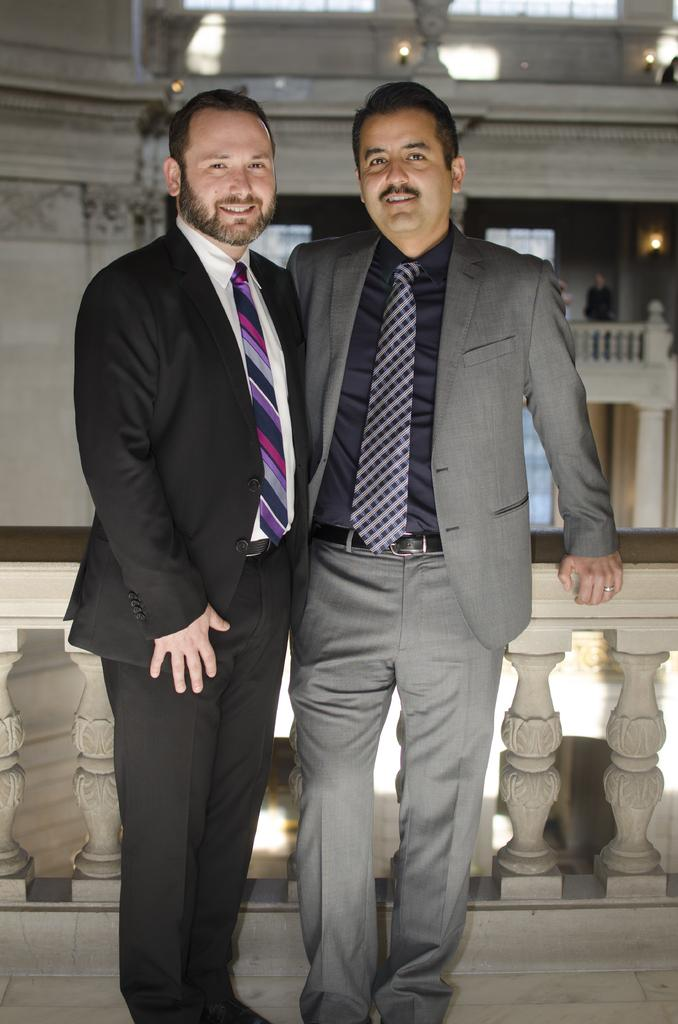How many people are in the image? There are two persons in the image. What are the persons wearing on their upper bodies? Both persons are wearing blazers and ties. What surface are the persons standing on? The persons are standing on the floor. What can be seen in the background of the image? There is an inner view of a building in the background of the image. What type of lizards can be seen crawling on the persons' blazers in the image? There are no lizards present in the image; the persons are wearing blazers and ties. What is the weather like in the image, considering the attire of the persons? The provided facts do not mention the weather, and the attire of the persons does not give any indication of the weather conditions. 